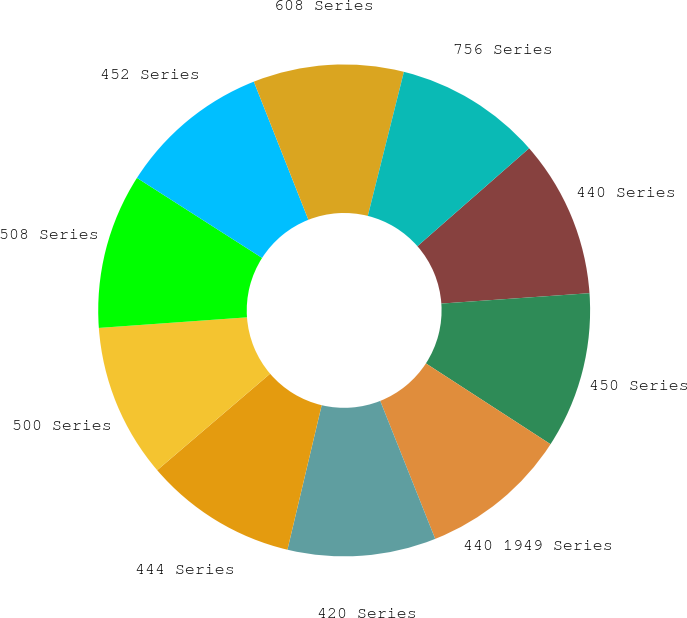<chart> <loc_0><loc_0><loc_500><loc_500><pie_chart><fcel>440 Series<fcel>450 Series<fcel>440 1949 Series<fcel>420 Series<fcel>444 Series<fcel>500 Series<fcel>508 Series<fcel>452 Series<fcel>608 Series<fcel>756 Series<nl><fcel>10.34%<fcel>10.27%<fcel>9.81%<fcel>9.74%<fcel>10.04%<fcel>10.12%<fcel>10.19%<fcel>9.96%<fcel>9.89%<fcel>9.64%<nl></chart> 